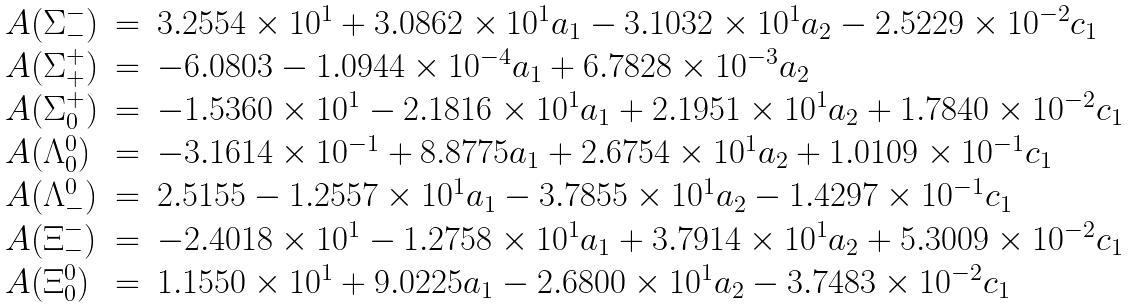<formula> <loc_0><loc_0><loc_500><loc_500>\begin{array} { l c l } A ( \Sigma ^ { - } _ { - } ) & = & 3 . 2 5 5 4 \times 1 0 ^ { 1 } + 3 . 0 8 6 2 \times 1 0 ^ { 1 } a _ { 1 } - 3 . 1 0 3 2 \times 1 0 ^ { 1 } a _ { 2 } - 2 . 5 2 2 9 \times 1 0 ^ { - 2 } c _ { 1 } \\ A ( \Sigma ^ { + } _ { + } ) & = & - 6 . 0 8 0 3 - 1 . 0 9 4 4 \times 1 0 ^ { - 4 } a _ { 1 } + 6 . 7 8 2 8 \times 1 0 ^ { - 3 } a _ { 2 } \\ A ( \Sigma ^ { + } _ { 0 } ) & = & - 1 . 5 3 6 0 \times 1 0 ^ { 1 } - 2 . 1 8 1 6 \times 1 0 ^ { 1 } a _ { 1 } + 2 . 1 9 5 1 \times 1 0 ^ { 1 } a _ { 2 } + 1 . 7 8 4 0 \times 1 0 ^ { - 2 } c _ { 1 } \\ A ( \Lambda ^ { 0 } _ { 0 } ) & = & - 3 . 1 6 1 4 \times 1 0 ^ { - 1 } + 8 . 8 7 7 5 a _ { 1 } + 2 . 6 7 5 4 \times 1 0 ^ { 1 } a _ { 2 } + 1 . 0 1 0 9 \times 1 0 ^ { - 1 } c _ { 1 } \\ A ( \Lambda ^ { 0 } _ { - } ) & = & 2 . 5 1 5 5 - 1 . 2 5 5 7 \times 1 0 ^ { 1 } a _ { 1 } - 3 . 7 8 5 5 \times 1 0 ^ { 1 } a _ { 2 } - 1 . 4 2 9 7 \times 1 0 ^ { - 1 } c _ { 1 } \\ A ( \Xi ^ { - } _ { - } ) & = & - 2 . 4 0 1 8 \times 1 0 ^ { 1 } - 1 . 2 7 5 8 \times 1 0 ^ { 1 } a _ { 1 } + 3 . 7 9 1 4 \times 1 0 ^ { 1 } a _ { 2 } + 5 . 3 0 0 9 \times 1 0 ^ { - 2 } c _ { 1 } \\ A ( \Xi ^ { 0 } _ { 0 } ) & = & 1 . 1 5 5 0 \times 1 0 ^ { 1 } + 9 . 0 2 2 5 a _ { 1 } - 2 . 6 8 0 0 \times 1 0 ^ { 1 } a _ { 2 } - 3 . 7 4 8 3 \times 1 0 ^ { - 2 } c _ { 1 } \end{array}</formula> 